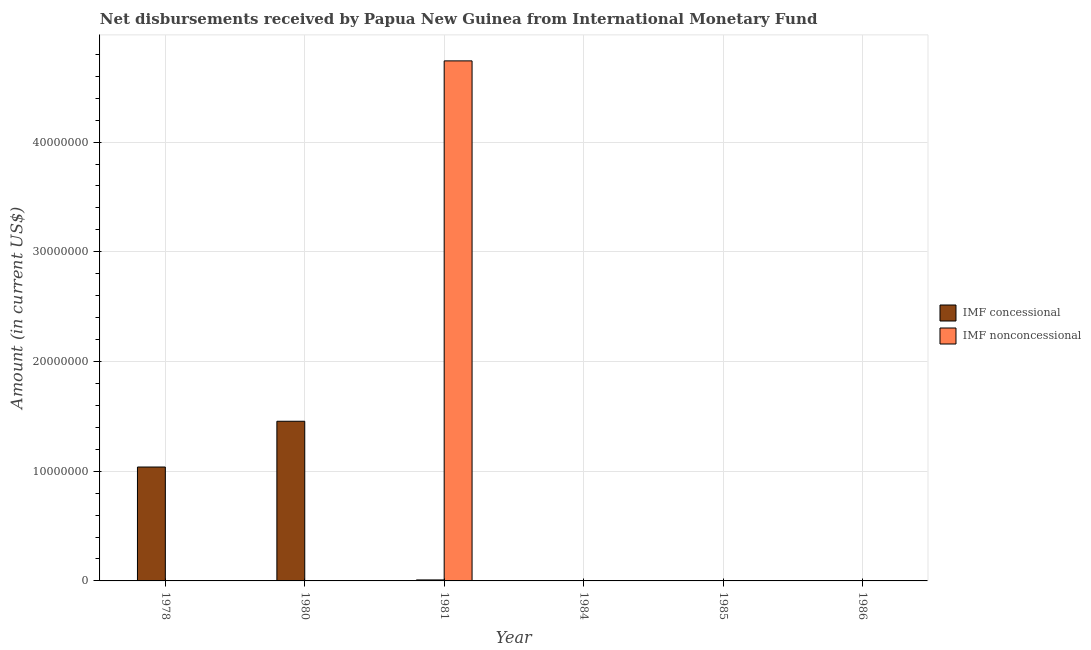How many bars are there on the 2nd tick from the left?
Ensure brevity in your answer.  1. In how many cases, is the number of bars for a given year not equal to the number of legend labels?
Keep it short and to the point. 5. What is the net concessional disbursements from imf in 1980?
Your response must be concise. 1.46e+07. Across all years, what is the maximum net non concessional disbursements from imf?
Ensure brevity in your answer.  4.74e+07. Across all years, what is the minimum net concessional disbursements from imf?
Ensure brevity in your answer.  0. What is the total net concessional disbursements from imf in the graph?
Ensure brevity in your answer.  2.50e+07. What is the difference between the net concessional disbursements from imf in 1978 and that in 1980?
Make the answer very short. -4.17e+06. What is the difference between the net concessional disbursements from imf in 1980 and the net non concessional disbursements from imf in 1985?
Make the answer very short. 1.46e+07. What is the average net concessional disbursements from imf per year?
Your answer should be very brief. 4.17e+06. What is the difference between the highest and the second highest net concessional disbursements from imf?
Your answer should be very brief. 4.17e+06. What is the difference between the highest and the lowest net concessional disbursements from imf?
Ensure brevity in your answer.  1.46e+07. What is the difference between two consecutive major ticks on the Y-axis?
Ensure brevity in your answer.  1.00e+07. How many legend labels are there?
Provide a succinct answer. 2. What is the title of the graph?
Offer a terse response. Net disbursements received by Papua New Guinea from International Monetary Fund. Does "Urban" appear as one of the legend labels in the graph?
Your answer should be compact. No. What is the label or title of the Y-axis?
Ensure brevity in your answer.  Amount (in current US$). What is the Amount (in current US$) of IMF concessional in 1978?
Offer a terse response. 1.04e+07. What is the Amount (in current US$) in IMF concessional in 1980?
Keep it short and to the point. 1.46e+07. What is the Amount (in current US$) of IMF nonconcessional in 1981?
Offer a very short reply. 4.74e+07. What is the Amount (in current US$) of IMF concessional in 1984?
Offer a terse response. 0. Across all years, what is the maximum Amount (in current US$) of IMF concessional?
Make the answer very short. 1.46e+07. Across all years, what is the maximum Amount (in current US$) of IMF nonconcessional?
Make the answer very short. 4.74e+07. Across all years, what is the minimum Amount (in current US$) in IMF concessional?
Provide a short and direct response. 0. Across all years, what is the minimum Amount (in current US$) in IMF nonconcessional?
Offer a terse response. 0. What is the total Amount (in current US$) of IMF concessional in the graph?
Your answer should be very brief. 2.50e+07. What is the total Amount (in current US$) in IMF nonconcessional in the graph?
Offer a terse response. 4.74e+07. What is the difference between the Amount (in current US$) in IMF concessional in 1978 and that in 1980?
Provide a short and direct response. -4.17e+06. What is the difference between the Amount (in current US$) of IMF concessional in 1978 and that in 1981?
Your response must be concise. 1.03e+07. What is the difference between the Amount (in current US$) of IMF concessional in 1980 and that in 1981?
Keep it short and to the point. 1.45e+07. What is the difference between the Amount (in current US$) of IMF concessional in 1978 and the Amount (in current US$) of IMF nonconcessional in 1981?
Offer a terse response. -3.70e+07. What is the difference between the Amount (in current US$) in IMF concessional in 1980 and the Amount (in current US$) in IMF nonconcessional in 1981?
Provide a succinct answer. -3.28e+07. What is the average Amount (in current US$) of IMF concessional per year?
Give a very brief answer. 4.17e+06. What is the average Amount (in current US$) in IMF nonconcessional per year?
Ensure brevity in your answer.  7.90e+06. In the year 1981, what is the difference between the Amount (in current US$) of IMF concessional and Amount (in current US$) of IMF nonconcessional?
Offer a terse response. -4.73e+07. What is the ratio of the Amount (in current US$) of IMF concessional in 1978 to that in 1980?
Offer a very short reply. 0.71. What is the ratio of the Amount (in current US$) in IMF concessional in 1978 to that in 1981?
Make the answer very short. 115.34. What is the ratio of the Amount (in current US$) in IMF concessional in 1980 to that in 1981?
Offer a very short reply. 161.69. What is the difference between the highest and the second highest Amount (in current US$) in IMF concessional?
Give a very brief answer. 4.17e+06. What is the difference between the highest and the lowest Amount (in current US$) of IMF concessional?
Offer a terse response. 1.46e+07. What is the difference between the highest and the lowest Amount (in current US$) in IMF nonconcessional?
Provide a short and direct response. 4.74e+07. 